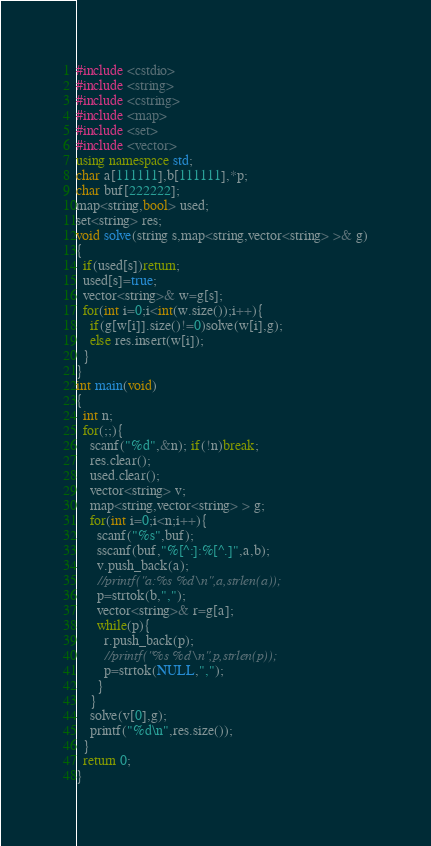Convert code to text. <code><loc_0><loc_0><loc_500><loc_500><_C++_>#include <cstdio>
#include <string>
#include <cstring>
#include <map>
#include <set>
#include <vector>
using namespace std;
char a[111111],b[111111],*p;
char buf[222222];
map<string,bool> used;
set<string> res;
void solve(string s,map<string,vector<string> >& g)
{
  if(used[s])return;
  used[s]=true;
  vector<string>& w=g[s];
  for(int i=0;i<int(w.size());i++){
    if(g[w[i]].size()!=0)solve(w[i],g);
    else res.insert(w[i]);
  }
}
int main(void)
{
  int n;
  for(;;){
    scanf("%d",&n); if(!n)break;
    res.clear();
    used.clear();
    vector<string> v;
    map<string,vector<string> > g;
    for(int i=0;i<n;i++){
      scanf("%s",buf);
      sscanf(buf,"%[^:]:%[^.]",a,b);
      v.push_back(a);
      //printf("a:%s %d\n",a,strlen(a));
      p=strtok(b,",");
      vector<string>& r=g[a];
      while(p){
        r.push_back(p);
        //printf("%s %d\n",p,strlen(p));
        p=strtok(NULL,",");
      }
    }
    solve(v[0],g);
    printf("%d\n",res.size());
  }
  return 0;
}</code> 